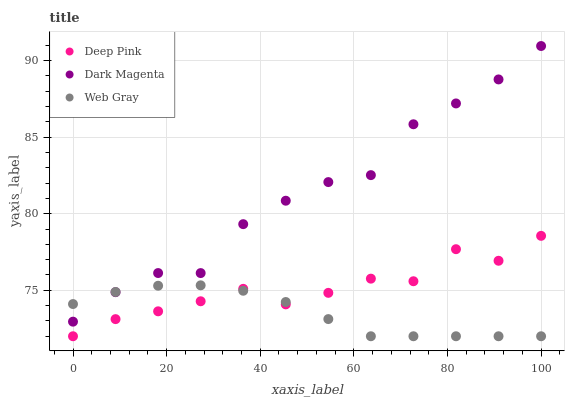Does Web Gray have the minimum area under the curve?
Answer yes or no. Yes. Does Dark Magenta have the maximum area under the curve?
Answer yes or no. Yes. Does Dark Magenta have the minimum area under the curve?
Answer yes or no. No. Does Web Gray have the maximum area under the curve?
Answer yes or no. No. Is Web Gray the smoothest?
Answer yes or no. Yes. Is Dark Magenta the roughest?
Answer yes or no. Yes. Is Dark Magenta the smoothest?
Answer yes or no. No. Is Web Gray the roughest?
Answer yes or no. No. Does Deep Pink have the lowest value?
Answer yes or no. Yes. Does Dark Magenta have the lowest value?
Answer yes or no. No. Does Dark Magenta have the highest value?
Answer yes or no. Yes. Does Web Gray have the highest value?
Answer yes or no. No. Is Deep Pink less than Dark Magenta?
Answer yes or no. Yes. Is Dark Magenta greater than Deep Pink?
Answer yes or no. Yes. Does Web Gray intersect Deep Pink?
Answer yes or no. Yes. Is Web Gray less than Deep Pink?
Answer yes or no. No. Is Web Gray greater than Deep Pink?
Answer yes or no. No. Does Deep Pink intersect Dark Magenta?
Answer yes or no. No. 